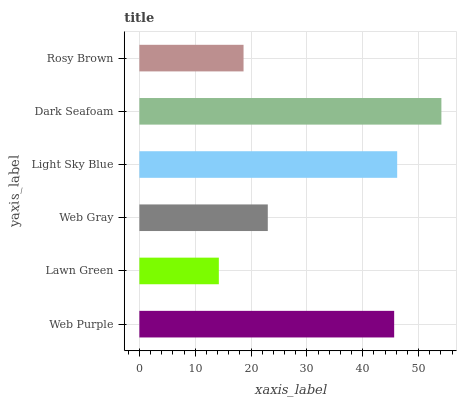Is Lawn Green the minimum?
Answer yes or no. Yes. Is Dark Seafoam the maximum?
Answer yes or no. Yes. Is Web Gray the minimum?
Answer yes or no. No. Is Web Gray the maximum?
Answer yes or no. No. Is Web Gray greater than Lawn Green?
Answer yes or no. Yes. Is Lawn Green less than Web Gray?
Answer yes or no. Yes. Is Lawn Green greater than Web Gray?
Answer yes or no. No. Is Web Gray less than Lawn Green?
Answer yes or no. No. Is Web Purple the high median?
Answer yes or no. Yes. Is Web Gray the low median?
Answer yes or no. Yes. Is Web Gray the high median?
Answer yes or no. No. Is Web Purple the low median?
Answer yes or no. No. 